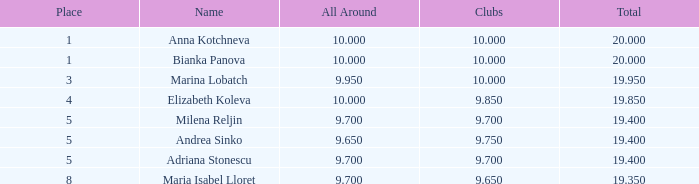What is the highest total that has andrea sinko as the name, with an all around greater than 9.65? None. 